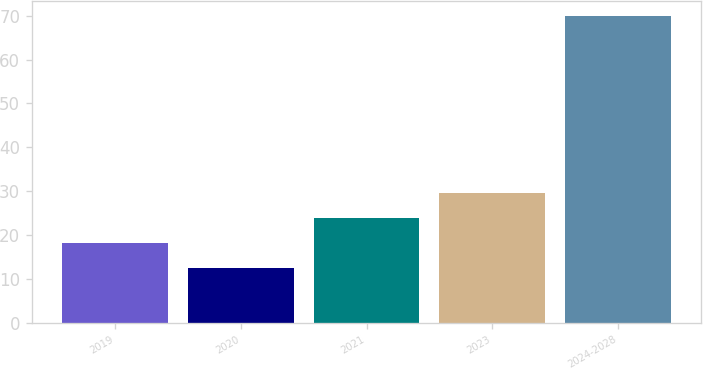<chart> <loc_0><loc_0><loc_500><loc_500><bar_chart><fcel>2019<fcel>2020<fcel>2021<fcel>2023<fcel>2024-2028<nl><fcel>18.15<fcel>12.4<fcel>23.9<fcel>29.65<fcel>69.9<nl></chart> 